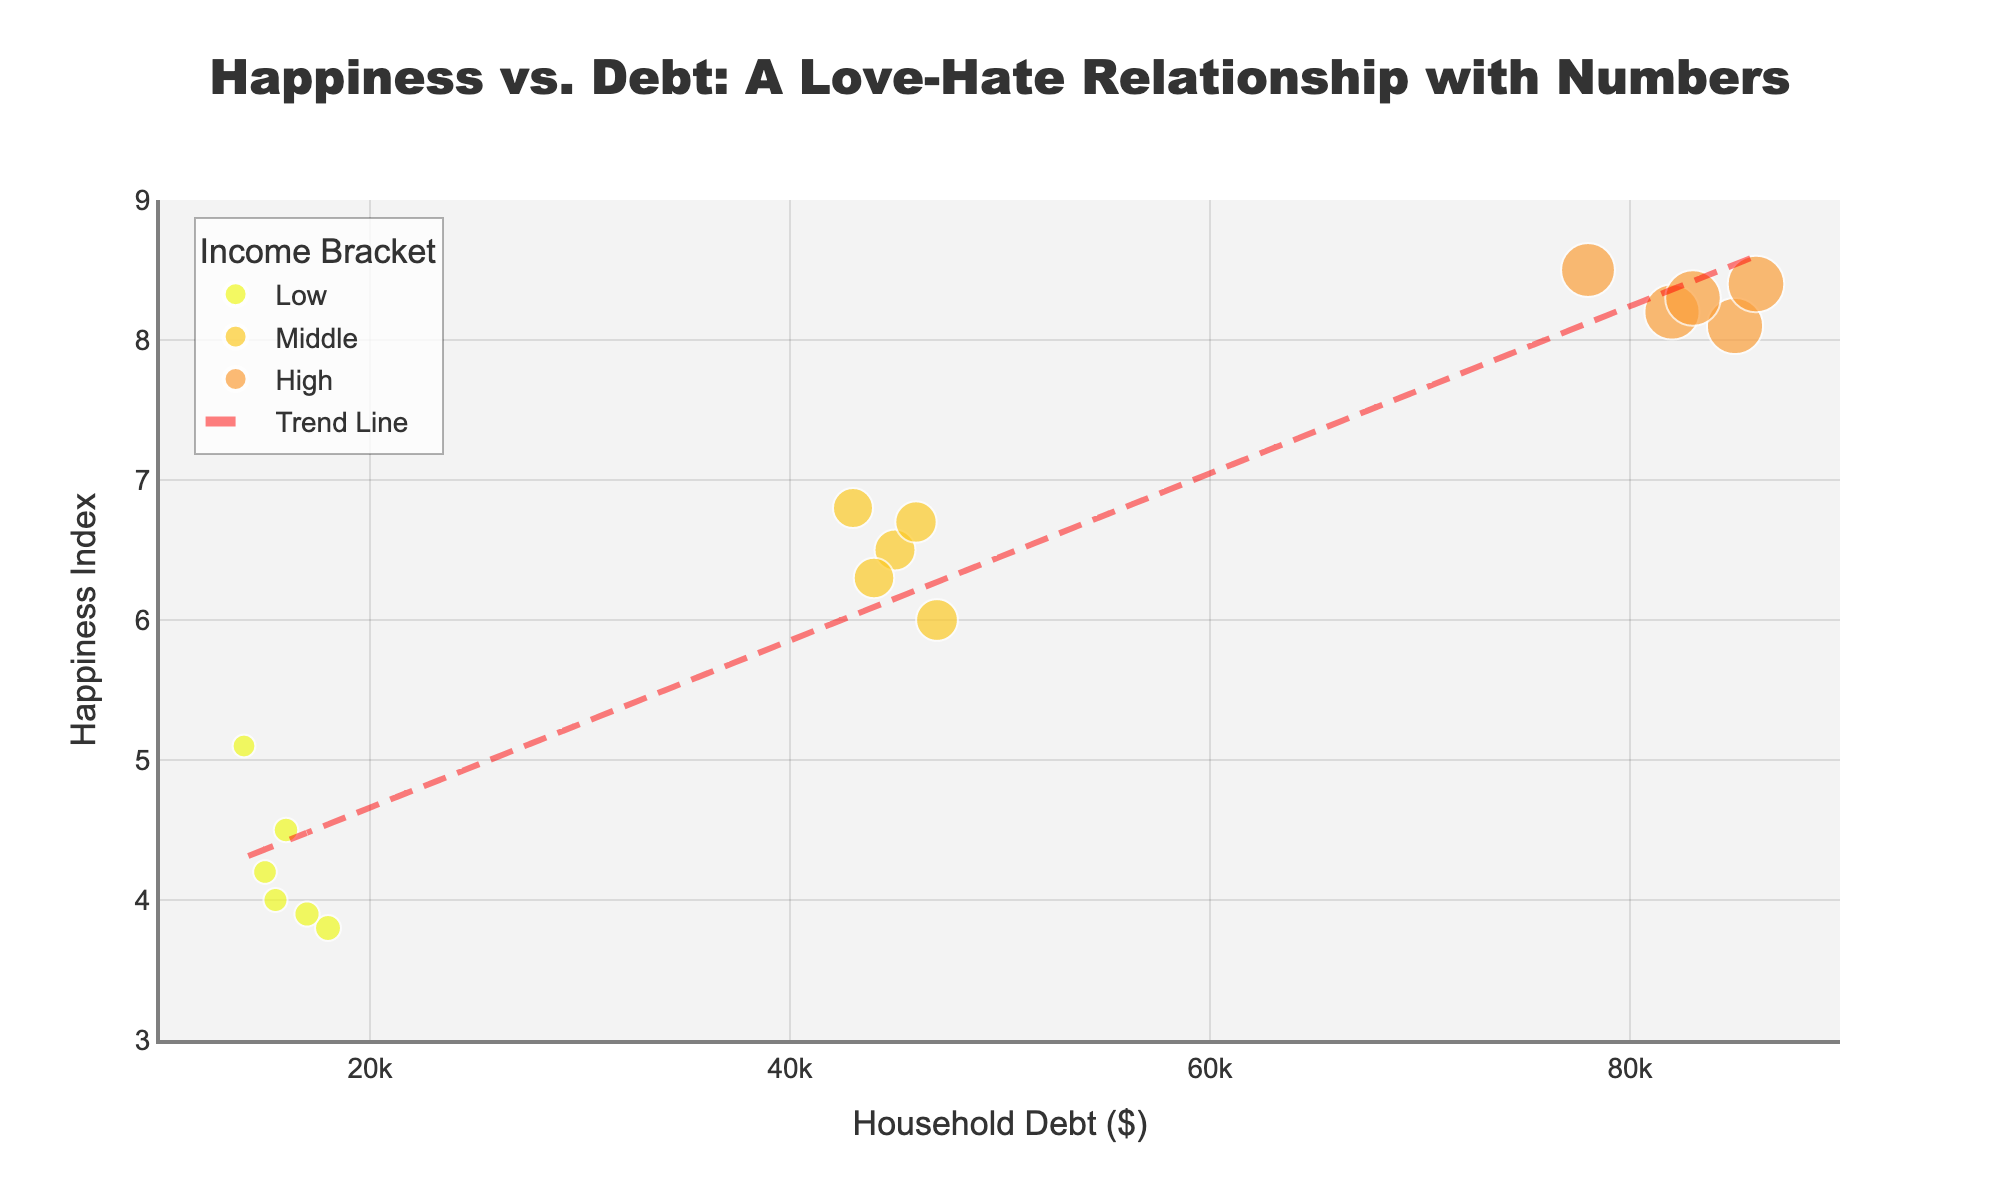How many distinct income brackets are represented in the plot? The plot has separate colors for each income bracket, which can be counted visually. Identifying the different colors, we see three - indicating three different income brackets: Low, Middle, and High.
Answer: 3 What is the title of the scatter plot? The title is displayed prominently at the top-center of the plot. It reads: "Happiness vs. Debt: A Love-Hate Relationship with Numbers".
Answer: Happiness vs. Debt: A Love-Hate Relationship with Numbers What is the range of the Household Debt axis? The x-axis, labeled "Household Debt ($)" at the bottom of the chart, spans from 10,000 to 90,000, as indicated by the numerical ticks and the axis range.
Answer: 10,000 to 90,000 Describe the trend line added to the scatter plot. The trend line runs through the points on the scatter plot, following a linear pattern. It is dashed, colored in a red tint, and titled "Trend Line." The line visually shows a tendency between Household Debt and Happiness Index.
Answer: Linear pattern, red, dashed Which income bracket has the highest Happiness Index, and what is the approximate value? Observing the plot, the highest Happiness Index (8.5) is found within the High-income bracket, indicated by the data points color-coded for the High category.
Answer: High, 8.5 What does the trend line suggest about the relationship between Household Debt and Happiness Index? The slope of the trend line, which goes upwards as it moves right, indicates a positive relationship. This suggests that as Household Debt increases, the Happiness Index also tends to increase.
Answer: Positive relationship Comparing the household debt, which income bracket seems to have the highest range of debt levels? The High-income bracket has data points with debt levels ranging roughly from 78,000 to 86,000, a larger spread compared to Low and Middle brackets.
Answer: High What is the average Happiness Index for the Middle-income brackets? For the Middle-income bracket, the Happiness Index values are 6.5, 6.0, 6.8, 6.3, and 6.7. Adding these values (6.5 + 6.0 + 6.8 + 6.3 + 6.7 = 32.3) and dividing by the number of points (5), the average is 32.3/5 = 6.46.
Answer: 6.46 Is there a data point with a Happiness Index below 4, and which income bracket does it belong to? Yes, there is a data point with a Happiness Index of 3.8, which falls below 4, and it belongs to the Low-income bracket as indicated by the color coding.
Answer: Yes, Low 